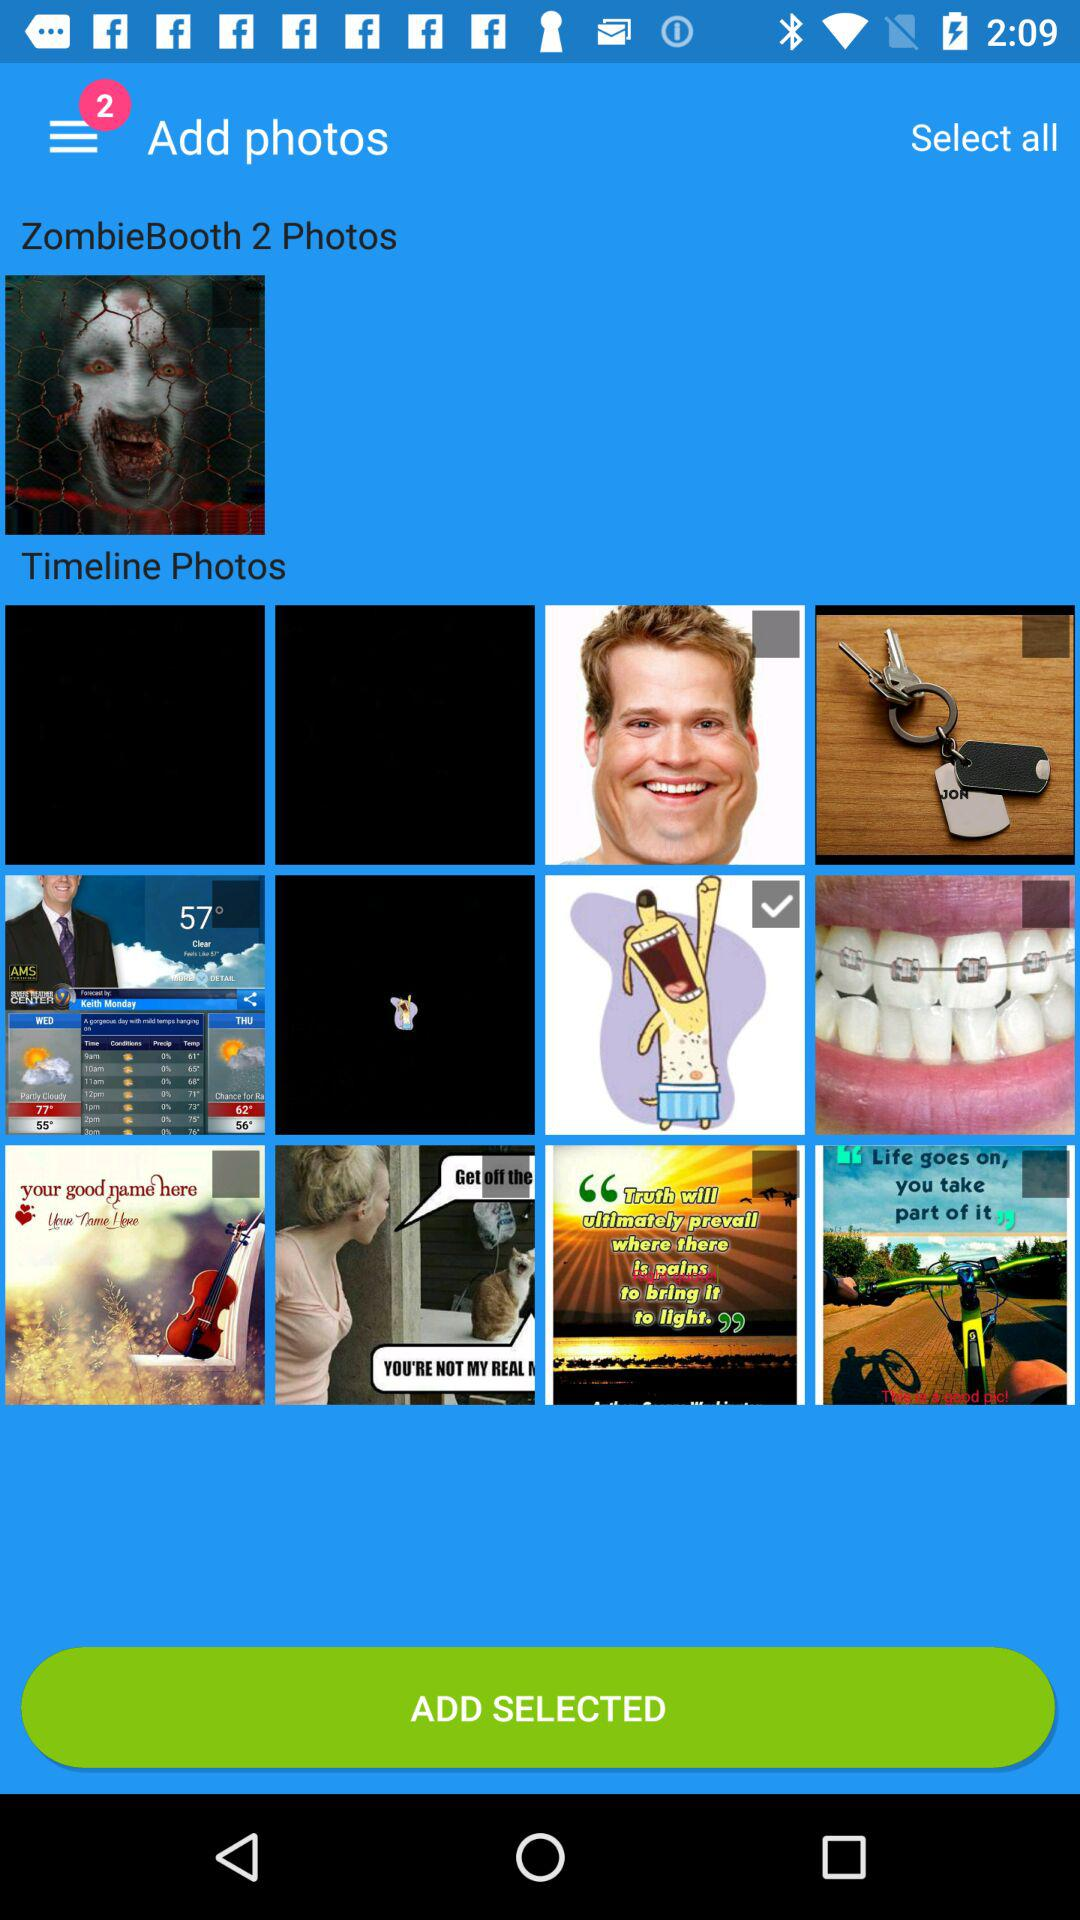How many photos are there in ZombieBooth? There are 2 photos. 